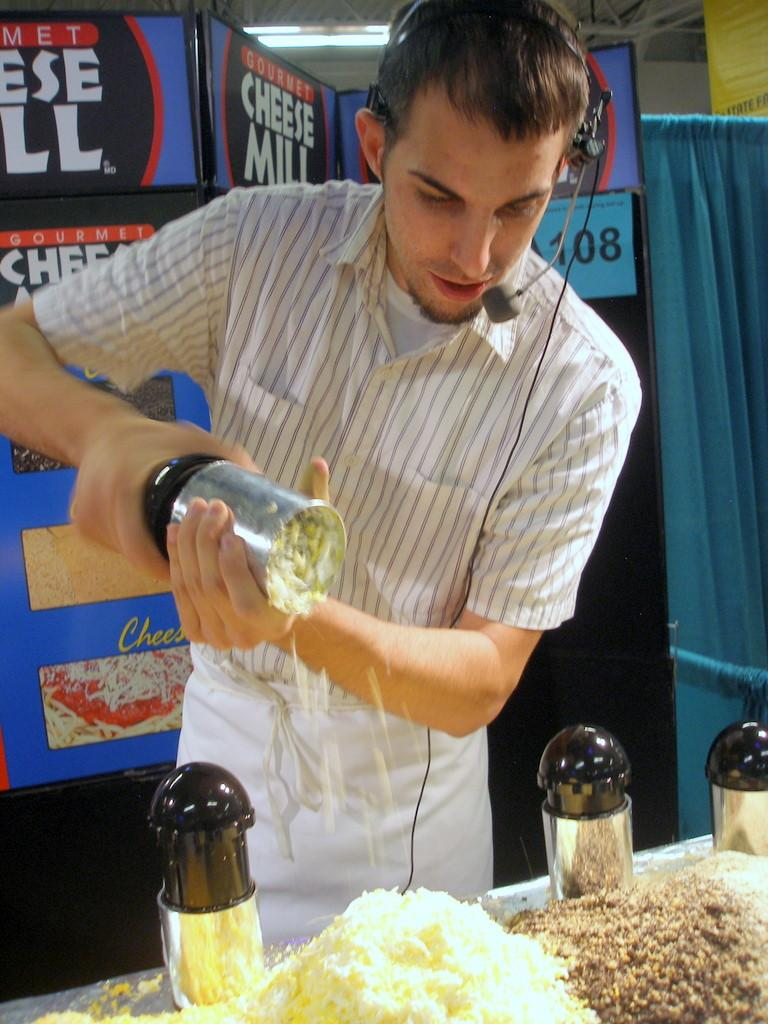<image>
Provide a brief description of the given image. A man grating cheese stands in front of several signs that read Gourmet Cheese Mill. 